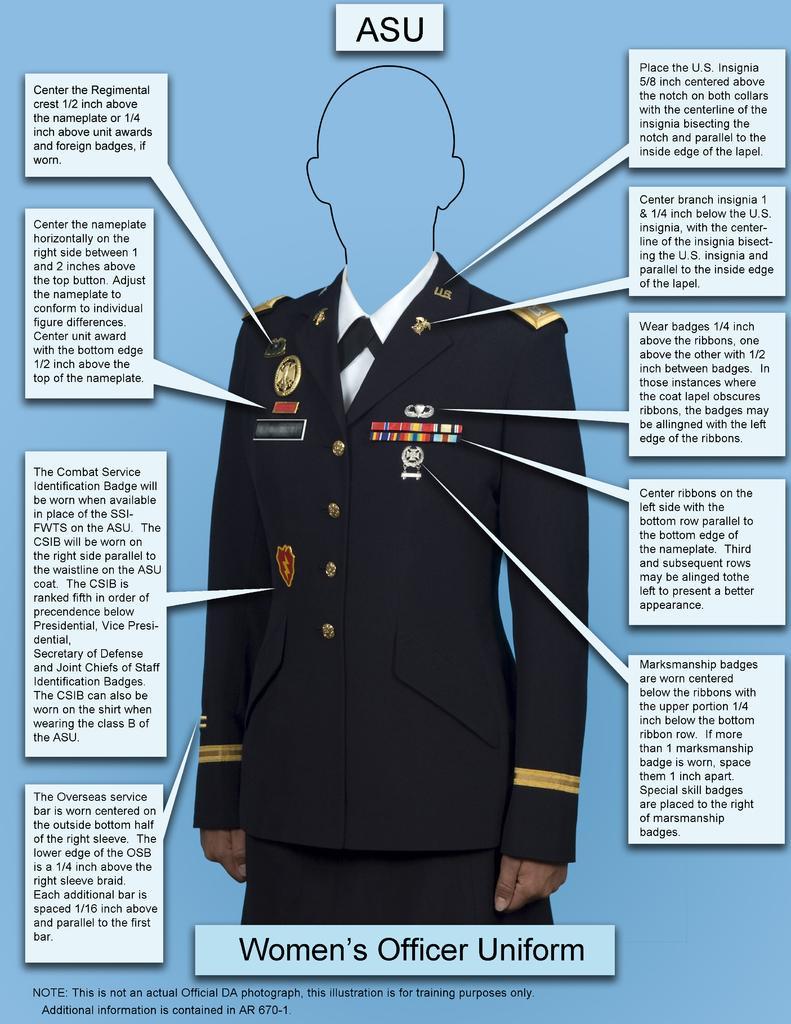Could you give a brief overview of what you see in this image? This is a poster with comments. Also we can see a uniform with badges. 